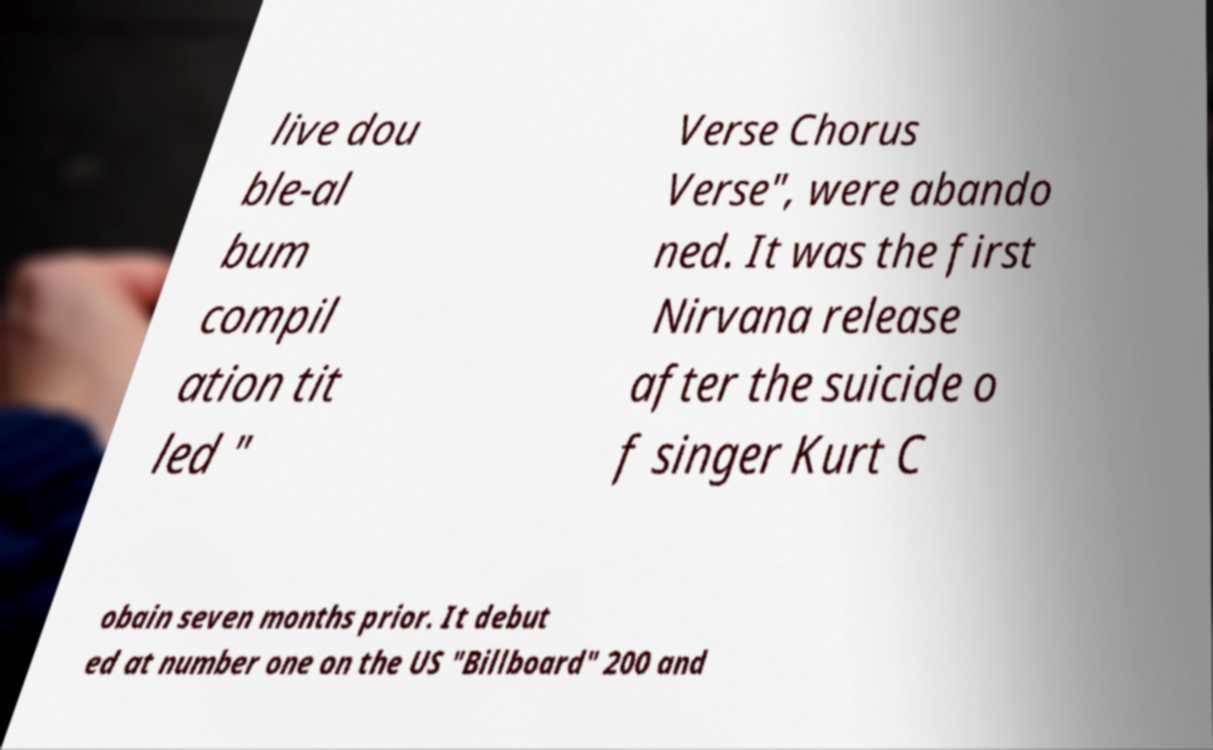I need the written content from this picture converted into text. Can you do that? live dou ble-al bum compil ation tit led " Verse Chorus Verse", were abando ned. It was the first Nirvana release after the suicide o f singer Kurt C obain seven months prior. It debut ed at number one on the US "Billboard" 200 and 